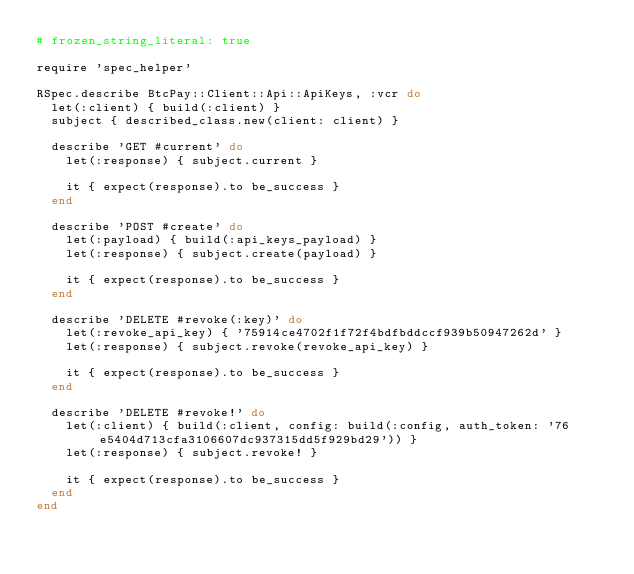<code> <loc_0><loc_0><loc_500><loc_500><_Ruby_># frozen_string_literal: true

require 'spec_helper'

RSpec.describe BtcPay::Client::Api::ApiKeys, :vcr do
  let(:client) { build(:client) }
  subject { described_class.new(client: client) }

  describe 'GET #current' do
    let(:response) { subject.current }

    it { expect(response).to be_success }
  end

  describe 'POST #create' do
    let(:payload) { build(:api_keys_payload) }
    let(:response) { subject.create(payload) }

    it { expect(response).to be_success }
  end

  describe 'DELETE #revoke(:key)' do
    let(:revoke_api_key) { '75914ce4702f1f72f4bdfbddccf939b50947262d' }
    let(:response) { subject.revoke(revoke_api_key) }

    it { expect(response).to be_success }
  end

  describe 'DELETE #revoke!' do
    let(:client) { build(:client, config: build(:config, auth_token: '76e5404d713cfa3106607dc937315dd5f929bd29')) }
    let(:response) { subject.revoke! }

    it { expect(response).to be_success }
  end
end
</code> 